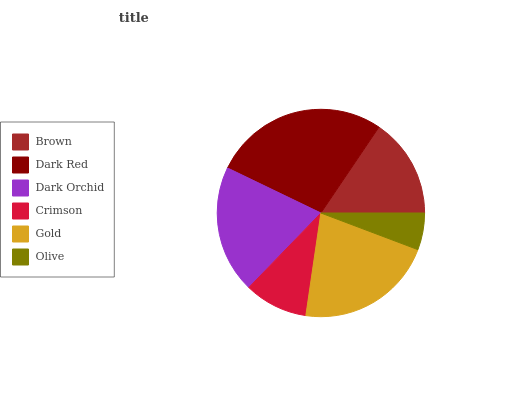Is Olive the minimum?
Answer yes or no. Yes. Is Dark Red the maximum?
Answer yes or no. Yes. Is Dark Orchid the minimum?
Answer yes or no. No. Is Dark Orchid the maximum?
Answer yes or no. No. Is Dark Red greater than Dark Orchid?
Answer yes or no. Yes. Is Dark Orchid less than Dark Red?
Answer yes or no. Yes. Is Dark Orchid greater than Dark Red?
Answer yes or no. No. Is Dark Red less than Dark Orchid?
Answer yes or no. No. Is Dark Orchid the high median?
Answer yes or no. Yes. Is Brown the low median?
Answer yes or no. Yes. Is Gold the high median?
Answer yes or no. No. Is Crimson the low median?
Answer yes or no. No. 